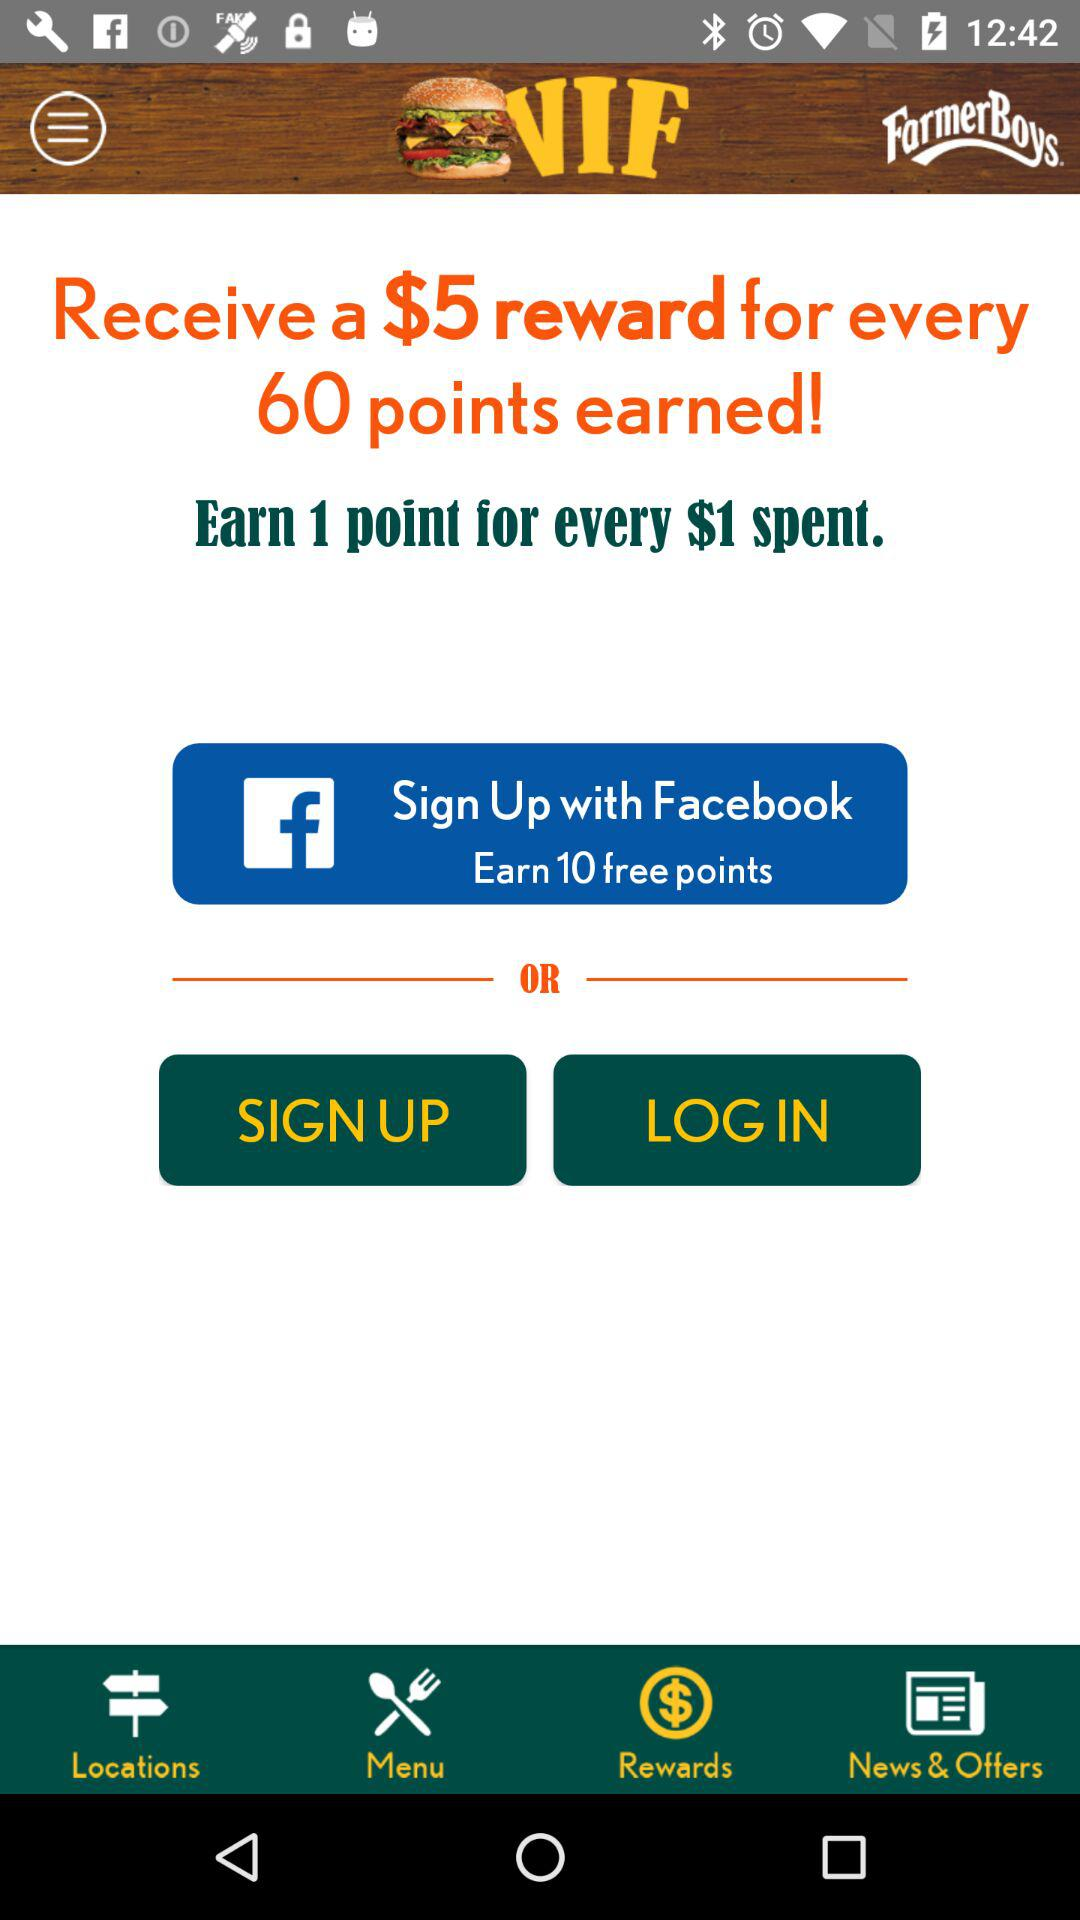How many points are needed to earn a $5 reward?
Answer the question using a single word or phrase. 60 